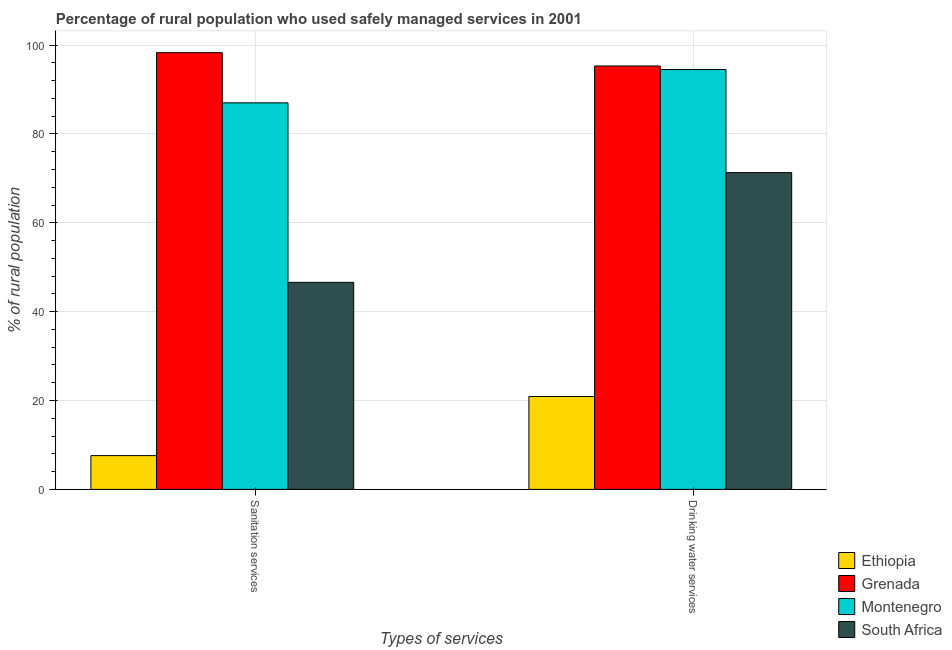How many different coloured bars are there?
Your response must be concise. 4. Are the number of bars per tick equal to the number of legend labels?
Keep it short and to the point. Yes. What is the label of the 1st group of bars from the left?
Offer a very short reply. Sanitation services. Across all countries, what is the maximum percentage of rural population who used drinking water services?
Your answer should be compact. 95.3. Across all countries, what is the minimum percentage of rural population who used drinking water services?
Make the answer very short. 20.9. In which country was the percentage of rural population who used sanitation services maximum?
Ensure brevity in your answer.  Grenada. In which country was the percentage of rural population who used sanitation services minimum?
Make the answer very short. Ethiopia. What is the total percentage of rural population who used sanitation services in the graph?
Ensure brevity in your answer.  239.5. What is the difference between the percentage of rural population who used sanitation services in South Africa and that in Montenegro?
Provide a short and direct response. -40.4. What is the difference between the percentage of rural population who used drinking water services in Grenada and the percentage of rural population who used sanitation services in South Africa?
Your response must be concise. 48.7. What is the average percentage of rural population who used sanitation services per country?
Make the answer very short. 59.87. What is the difference between the percentage of rural population who used drinking water services and percentage of rural population who used sanitation services in South Africa?
Your response must be concise. 24.7. In how many countries, is the percentage of rural population who used sanitation services greater than 40 %?
Offer a terse response. 3. What is the ratio of the percentage of rural population who used drinking water services in Ethiopia to that in South Africa?
Keep it short and to the point. 0.29. Is the percentage of rural population who used drinking water services in South Africa less than that in Montenegro?
Your answer should be very brief. Yes. In how many countries, is the percentage of rural population who used drinking water services greater than the average percentage of rural population who used drinking water services taken over all countries?
Your answer should be compact. 3. What does the 1st bar from the left in Drinking water services represents?
Your answer should be very brief. Ethiopia. What does the 3rd bar from the right in Drinking water services represents?
Your answer should be compact. Grenada. How many bars are there?
Your answer should be very brief. 8. How many countries are there in the graph?
Ensure brevity in your answer.  4. What is the difference between two consecutive major ticks on the Y-axis?
Make the answer very short. 20. Are the values on the major ticks of Y-axis written in scientific E-notation?
Your answer should be very brief. No. Does the graph contain grids?
Offer a terse response. Yes. Where does the legend appear in the graph?
Your answer should be very brief. Bottom right. How are the legend labels stacked?
Your answer should be compact. Vertical. What is the title of the graph?
Keep it short and to the point. Percentage of rural population who used safely managed services in 2001. What is the label or title of the X-axis?
Your answer should be compact. Types of services. What is the label or title of the Y-axis?
Make the answer very short. % of rural population. What is the % of rural population in Grenada in Sanitation services?
Offer a very short reply. 98.3. What is the % of rural population in Montenegro in Sanitation services?
Offer a very short reply. 87. What is the % of rural population in South Africa in Sanitation services?
Provide a succinct answer. 46.6. What is the % of rural population in Ethiopia in Drinking water services?
Ensure brevity in your answer.  20.9. What is the % of rural population in Grenada in Drinking water services?
Provide a succinct answer. 95.3. What is the % of rural population in Montenegro in Drinking water services?
Provide a short and direct response. 94.5. What is the % of rural population in South Africa in Drinking water services?
Offer a very short reply. 71.3. Across all Types of services, what is the maximum % of rural population in Ethiopia?
Keep it short and to the point. 20.9. Across all Types of services, what is the maximum % of rural population of Grenada?
Provide a short and direct response. 98.3. Across all Types of services, what is the maximum % of rural population of Montenegro?
Your answer should be compact. 94.5. Across all Types of services, what is the maximum % of rural population of South Africa?
Make the answer very short. 71.3. Across all Types of services, what is the minimum % of rural population of Ethiopia?
Your response must be concise. 7.6. Across all Types of services, what is the minimum % of rural population in Grenada?
Offer a terse response. 95.3. Across all Types of services, what is the minimum % of rural population of South Africa?
Offer a terse response. 46.6. What is the total % of rural population in Grenada in the graph?
Your answer should be very brief. 193.6. What is the total % of rural population in Montenegro in the graph?
Make the answer very short. 181.5. What is the total % of rural population of South Africa in the graph?
Your answer should be very brief. 117.9. What is the difference between the % of rural population in Grenada in Sanitation services and that in Drinking water services?
Give a very brief answer. 3. What is the difference between the % of rural population of South Africa in Sanitation services and that in Drinking water services?
Provide a short and direct response. -24.7. What is the difference between the % of rural population of Ethiopia in Sanitation services and the % of rural population of Grenada in Drinking water services?
Provide a succinct answer. -87.7. What is the difference between the % of rural population in Ethiopia in Sanitation services and the % of rural population in Montenegro in Drinking water services?
Offer a terse response. -86.9. What is the difference between the % of rural population in Ethiopia in Sanitation services and the % of rural population in South Africa in Drinking water services?
Offer a terse response. -63.7. What is the difference between the % of rural population in Grenada in Sanitation services and the % of rural population in Montenegro in Drinking water services?
Provide a short and direct response. 3.8. What is the difference between the % of rural population of Grenada in Sanitation services and the % of rural population of South Africa in Drinking water services?
Provide a succinct answer. 27. What is the difference between the % of rural population of Montenegro in Sanitation services and the % of rural population of South Africa in Drinking water services?
Give a very brief answer. 15.7. What is the average % of rural population in Ethiopia per Types of services?
Offer a very short reply. 14.25. What is the average % of rural population in Grenada per Types of services?
Provide a succinct answer. 96.8. What is the average % of rural population of Montenegro per Types of services?
Your answer should be compact. 90.75. What is the average % of rural population of South Africa per Types of services?
Offer a very short reply. 58.95. What is the difference between the % of rural population in Ethiopia and % of rural population in Grenada in Sanitation services?
Provide a succinct answer. -90.7. What is the difference between the % of rural population of Ethiopia and % of rural population of Montenegro in Sanitation services?
Keep it short and to the point. -79.4. What is the difference between the % of rural population of Ethiopia and % of rural population of South Africa in Sanitation services?
Provide a succinct answer. -39. What is the difference between the % of rural population of Grenada and % of rural population of Montenegro in Sanitation services?
Your answer should be very brief. 11.3. What is the difference between the % of rural population of Grenada and % of rural population of South Africa in Sanitation services?
Make the answer very short. 51.7. What is the difference between the % of rural population in Montenegro and % of rural population in South Africa in Sanitation services?
Make the answer very short. 40.4. What is the difference between the % of rural population in Ethiopia and % of rural population in Grenada in Drinking water services?
Give a very brief answer. -74.4. What is the difference between the % of rural population of Ethiopia and % of rural population of Montenegro in Drinking water services?
Your answer should be compact. -73.6. What is the difference between the % of rural population in Ethiopia and % of rural population in South Africa in Drinking water services?
Keep it short and to the point. -50.4. What is the difference between the % of rural population of Montenegro and % of rural population of South Africa in Drinking water services?
Keep it short and to the point. 23.2. What is the ratio of the % of rural population of Ethiopia in Sanitation services to that in Drinking water services?
Provide a short and direct response. 0.36. What is the ratio of the % of rural population in Grenada in Sanitation services to that in Drinking water services?
Keep it short and to the point. 1.03. What is the ratio of the % of rural population of Montenegro in Sanitation services to that in Drinking water services?
Your answer should be compact. 0.92. What is the ratio of the % of rural population of South Africa in Sanitation services to that in Drinking water services?
Your response must be concise. 0.65. What is the difference between the highest and the second highest % of rural population of Ethiopia?
Make the answer very short. 13.3. What is the difference between the highest and the second highest % of rural population in South Africa?
Provide a short and direct response. 24.7. What is the difference between the highest and the lowest % of rural population in Ethiopia?
Your answer should be compact. 13.3. What is the difference between the highest and the lowest % of rural population in Montenegro?
Give a very brief answer. 7.5. What is the difference between the highest and the lowest % of rural population of South Africa?
Keep it short and to the point. 24.7. 